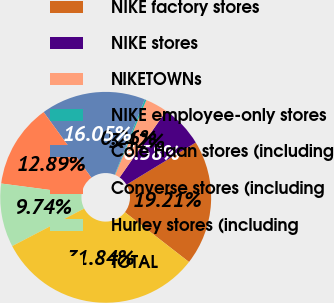Convert chart. <chart><loc_0><loc_0><loc_500><loc_500><pie_chart><fcel>NIKE factory stores<fcel>NIKE stores<fcel>NIKETOWNs<fcel>NIKE employee-only stores<fcel>Cole Haan stores (including<fcel>Converse stores (including<fcel>Hurley stores (including<fcel>TOTAL<nl><fcel>19.21%<fcel>6.58%<fcel>3.42%<fcel>0.26%<fcel>16.05%<fcel>12.89%<fcel>9.74%<fcel>31.84%<nl></chart> 